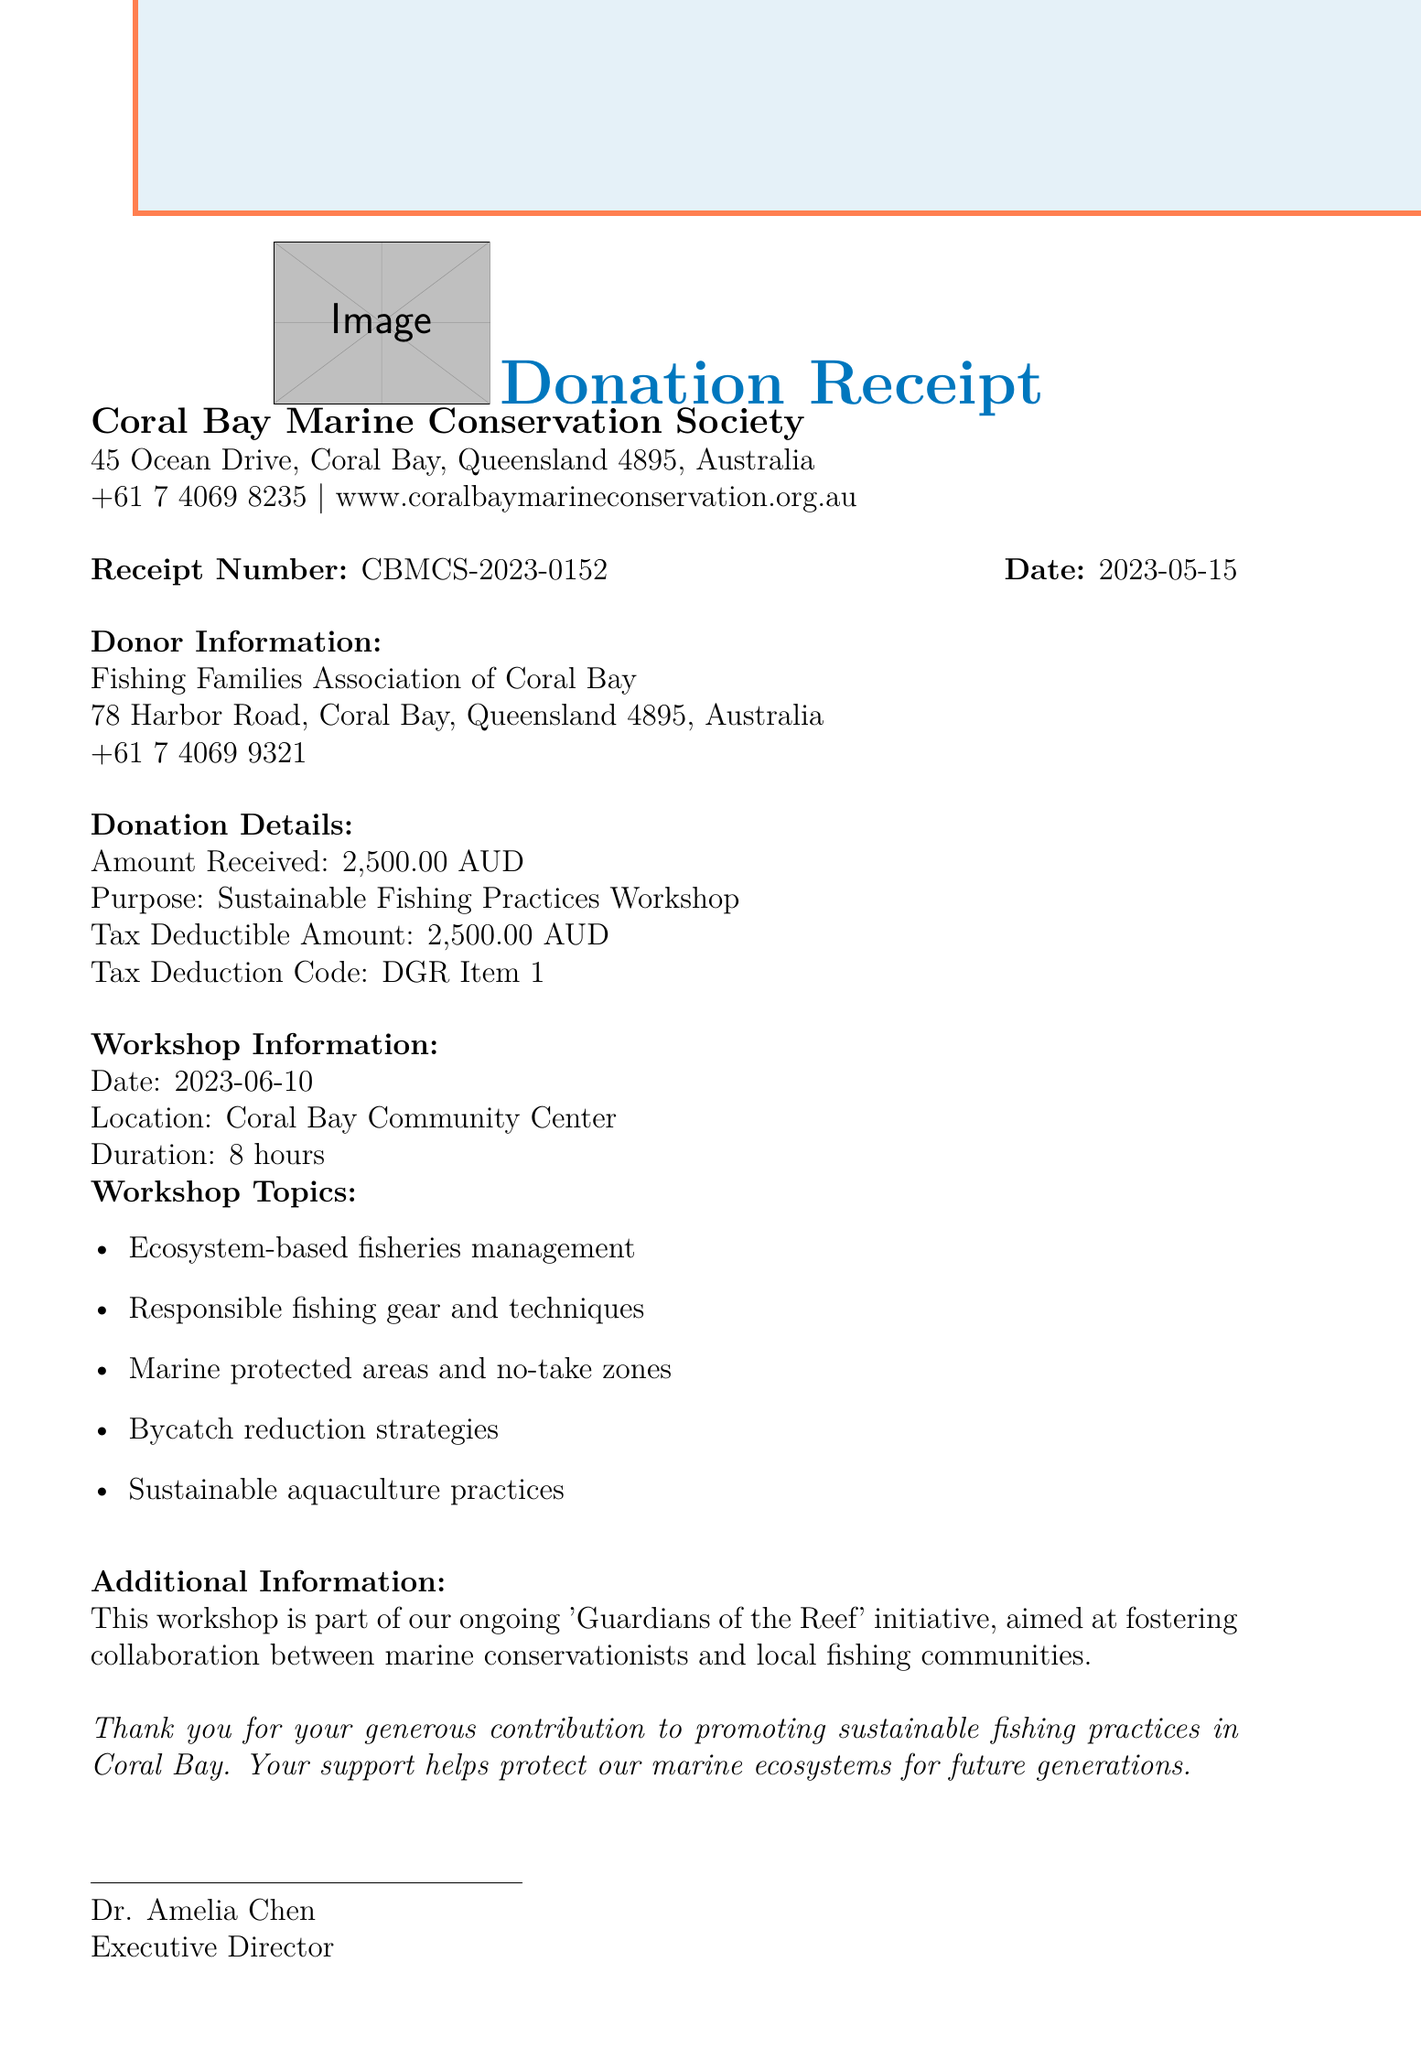What is the donation amount? The donation amount is stated directly in the document.
Answer: 2,500.00 AUD Who is the authorized signatory? The document specifies the person who signed as the authorized signatory.
Answer: Dr. Amelia Chen What is the purpose of the donation? The purpose of the donation is clearly mentioned in the document.
Answer: Sustainable Fishing Practices Workshop When did the donation take place? The date of the donation is explicitly provided in the document.
Answer: 2023-05-15 What is the tax deduction code? The tax deduction code is included in the donation details section.
Answer: DGR Item 1 How many hours is the workshop scheduled for? The duration of the workshop is specified in the document.
Answer: 8 hours What does the additional information section refer to? The additional information section outlines the context of the workshop and its initiative.
Answer: Guardians of the Reef What is the organization registration number? The registration number of the organization is provided at the end of the document.
Answer: 12345678 Where is the workshop going to take place? The location of the workshop is explicitly stated in the document.
Answer: Coral Bay Community Center 